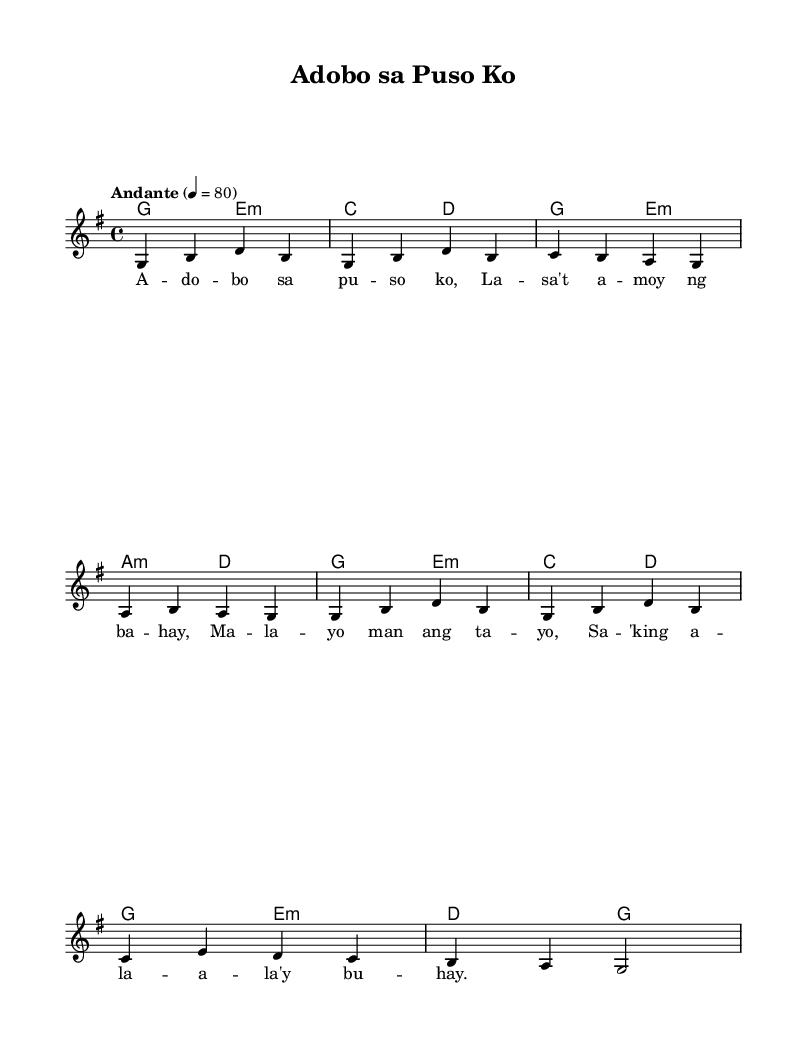What is the key signature of this music? The key signature is indicated by the sharp or flat symbols at the beginning of the staff. In this case, there are no accidentals shown, which means it is in G major or E minor. However, the context in the header suggests G major.
Answer: G major What is the time signature of this music? The time signature is found at the beginning of the staff, represented by the numbers above the bar lines. Here, it reads 4/4, meaning there are four beats in each measure, and the quarter note gets one beat.
Answer: 4/4 What is the tempo marking for this piece? The tempo marking is indicated above the staff and expresses the speed of the piece. In this case, it is labeled "Andante" with a specific number indicating beats per minute (80), suggesting a moderate pace.
Answer: Andante How many measures are in the melody? To determine the number of measures, we count the number of bar lines in the melody part. Each bar line separates one measure from another. The melody shows eight measures counted by the four bar lines.
Answer: 8 What chord follows the first measure of the melody? We can find the chord that corresponds to the first measure by looking at the chord symbols applied to each measure below the staff. In this case, the first measure aligns with the G major chord.
Answer: G What is the lyrical theme of this song? The lyrics are related to the title and reflect sentiments towards a specific dish, which is 'Adobo.' The words convey feelings of love and belonging to home, as implied in the lyrics.
Answer: Love for home What are the last two chords of the harmony section? The last two chords can be determined by observing the chord progression indicated at the end of the harmony line. The final measures show "d" followed by "g," corresponding to a D major chord followed by a G major chord.
Answer: D, G 